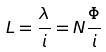Convert formula to latex. <formula><loc_0><loc_0><loc_500><loc_500>L = \frac { \lambda } { i } = N \frac { \Phi } { i }</formula> 